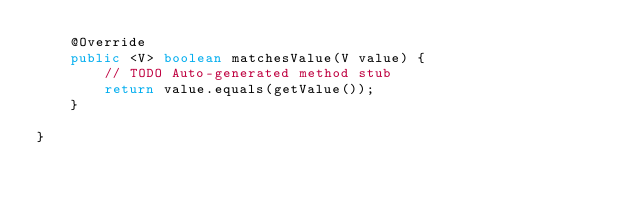Convert code to text. <code><loc_0><loc_0><loc_500><loc_500><_Java_>    @Override
    public <V> boolean matchesValue(V value) {
        // TODO Auto-generated method stub
        return value.equals(getValue());
    }

}
</code> 